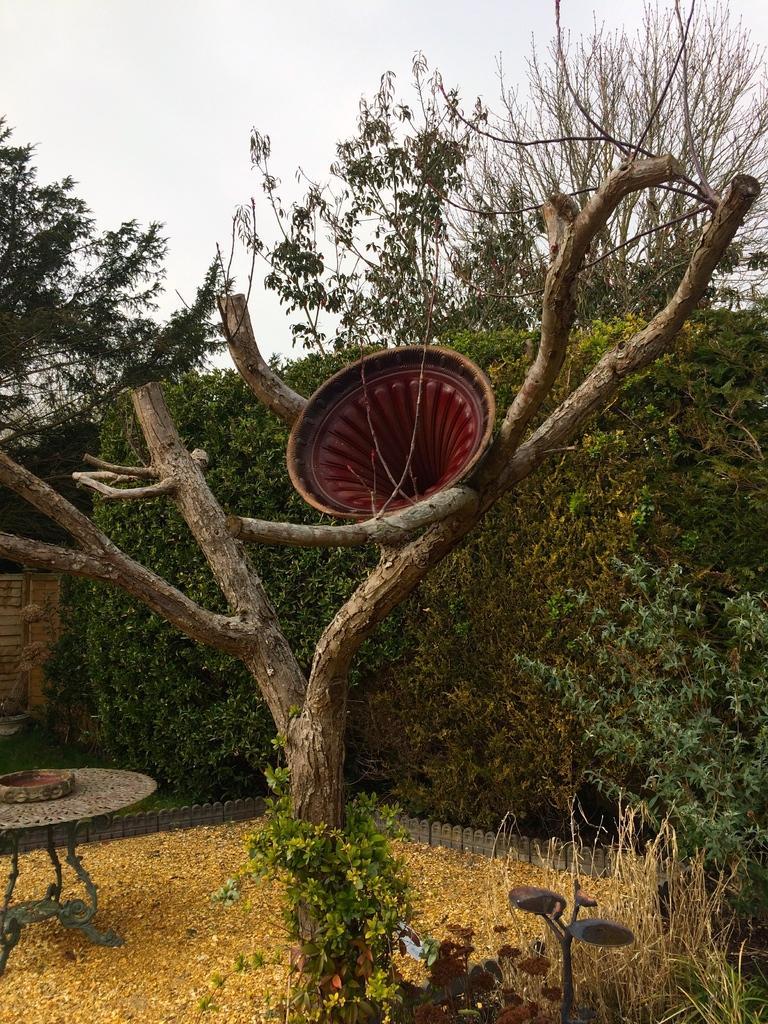How would you summarize this image in a sentence or two? In this image there is the sky towards the top of the image, there are trees, there are plants, there is an object on the tree, there is a table towards the left of the image, there is an object on the table, there is an object towards the bottom of the image, there is the grass. 